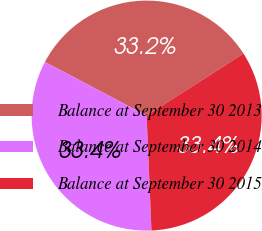<chart> <loc_0><loc_0><loc_500><loc_500><pie_chart><fcel>Balance at September 30 2013<fcel>Balance at September 30 2014<fcel>Balance at September 30 2015<nl><fcel>33.21%<fcel>33.39%<fcel>33.4%<nl></chart> 